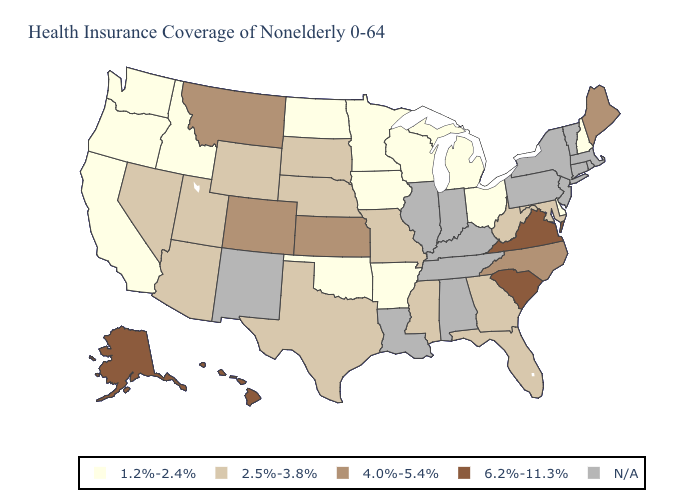How many symbols are there in the legend?
Give a very brief answer. 5. Which states hav the highest value in the South?
Short answer required. South Carolina, Virginia. Name the states that have a value in the range 4.0%-5.4%?
Be succinct. Colorado, Kansas, Maine, Montana, North Carolina. What is the highest value in the USA?
Concise answer only. 6.2%-11.3%. What is the lowest value in states that border Utah?
Give a very brief answer. 1.2%-2.4%. Name the states that have a value in the range 4.0%-5.4%?
Keep it brief. Colorado, Kansas, Maine, Montana, North Carolina. Name the states that have a value in the range 2.5%-3.8%?
Be succinct. Arizona, Florida, Georgia, Maryland, Mississippi, Missouri, Nebraska, Nevada, South Dakota, Texas, Utah, West Virginia, Wyoming. Name the states that have a value in the range 1.2%-2.4%?
Give a very brief answer. Arkansas, California, Delaware, Idaho, Iowa, Michigan, Minnesota, New Hampshire, North Dakota, Ohio, Oklahoma, Oregon, Washington, Wisconsin. Does Nebraska have the lowest value in the USA?
Answer briefly. No. What is the highest value in the USA?
Keep it brief. 6.2%-11.3%. Name the states that have a value in the range 1.2%-2.4%?
Answer briefly. Arkansas, California, Delaware, Idaho, Iowa, Michigan, Minnesota, New Hampshire, North Dakota, Ohio, Oklahoma, Oregon, Washington, Wisconsin. What is the value of Oregon?
Write a very short answer. 1.2%-2.4%. What is the value of California?
Give a very brief answer. 1.2%-2.4%. Which states have the lowest value in the USA?
Short answer required. Arkansas, California, Delaware, Idaho, Iowa, Michigan, Minnesota, New Hampshire, North Dakota, Ohio, Oklahoma, Oregon, Washington, Wisconsin. 